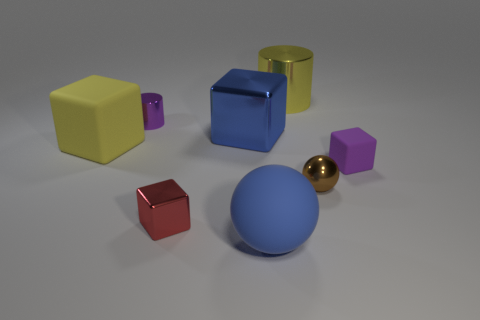Subtract all purple blocks. How many blocks are left? 3 Subtract all large shiny cubes. How many cubes are left? 3 Subtract all green cubes. Subtract all brown cylinders. How many cubes are left? 4 Add 1 yellow shiny objects. How many objects exist? 9 Subtract 1 purple cubes. How many objects are left? 7 Subtract all cylinders. How many objects are left? 6 Subtract 1 spheres. How many spheres are left? 1 Subtract all blue cylinders. How many gray blocks are left? 0 Subtract all purple rubber things. Subtract all big blue matte objects. How many objects are left? 6 Add 2 big blue objects. How many big blue objects are left? 4 